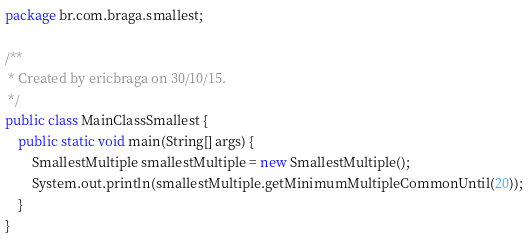<code> <loc_0><loc_0><loc_500><loc_500><_Java_>package br.com.braga.smallest;

/**
 * Created by ericbraga on 30/10/15.
 */
public class MainClassSmallest {
    public static void main(String[] args) {
        SmallestMultiple smallestMultiple = new SmallestMultiple();
        System.out.println(smallestMultiple.getMinimumMultipleCommonUntil(20));
    }
}
</code> 